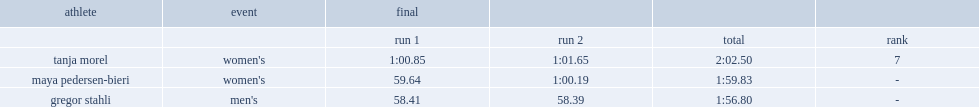What was the result that maya pedersen-bieri recorded in the women's? 59.64. 